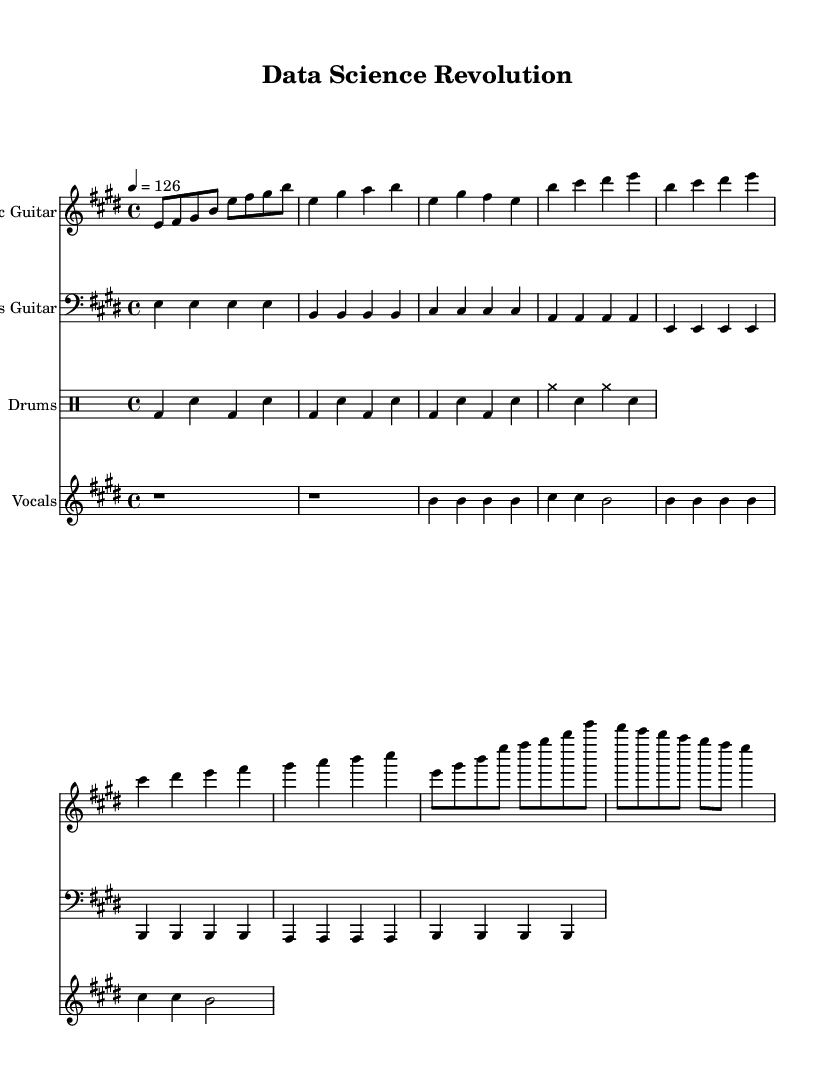What is the key signature of this music? The key is indicated at the beginning of the staff, showing two sharps which correspond to E major.
Answer: E major What is the time signature of this piece? The time signature, found at the beginning of the score, reads 4/4, indicating four beats per measure.
Answer: 4/4 What is the tempo marking for this piece? The tempo is given at the beginning with a metronome marking of 126 beats per minute.
Answer: 126 How many different instruments are present in this score? There are four distinct parts indicated in the score: Electric Guitar, Bass Guitar, Drums, and Vocals.
Answer: Four What is the lyrical theme suggested in the verse? The lyrics mention topics related to data and algorithms, suggesting an intellectual theme focused on data science.
Answer: Data science What type of musical section comes after the verse? The structure shows that a chorus follows the verse, indicated by a clear label in the lyrics part.
Answer: Chorus What rhythmic pattern is used in the drum part? The drum part features a consistent pattern alternating between bass drum and snare drum, indicating a steady rock rhythm.
Answer: Alternating bass and snare 